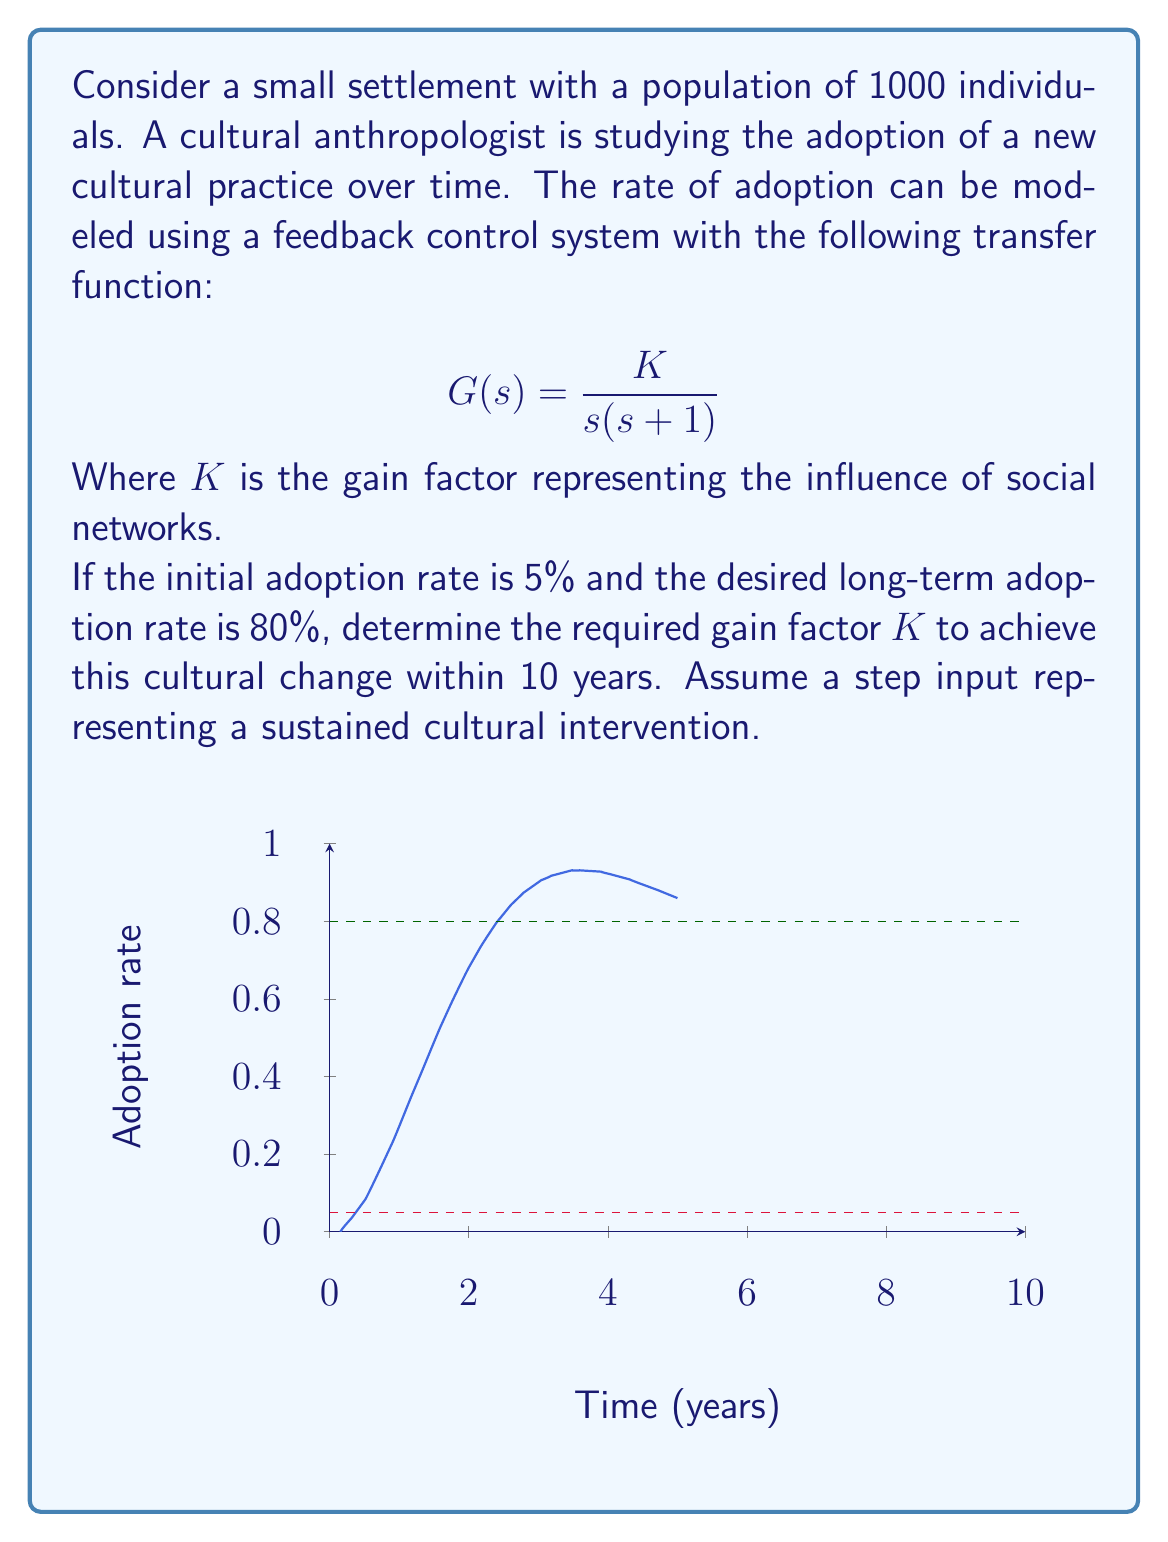Can you solve this math problem? To solve this problem, we'll follow these steps:

1) First, we need to determine the closed-loop transfer function. Given the open-loop transfer function $G(s) = \frac{K}{s(s+1)}$, the closed-loop transfer function is:

   $$T(s) = \frac{G(s)}{1+G(s)} = \frac{K}{s^2 + s + K}$$

2) The characteristic equation of this system is $s^2 + s + K = 0$. For a second-order system, we can express this in the standard form:

   $$s^2 + 2\zeta\omega_n s + \omega_n^2 = 0$$

   Where $\zeta$ is the damping ratio and $\omega_n$ is the natural frequency.

3) Comparing these equations, we can see that:
   
   $$2\zeta\omega_n = 1$$ and $$\omega_n^2 = K$$

4) For a step input, the steady-state value of the system response is:

   $$y_{ss} = \frac{K}{K} = 1$$

   This means the system will eventually reach 100% adoption, regardless of $K$.

5) To achieve 80% adoption in 10 years, we need to determine the settling time. For a 2% criterion, the settling time is approximately:

   $$T_s \approx \frac{4}{\zeta\omega_n}$$

6) We want the system to reach 80% of its final value in 10 years, so:

   $$10 = \frac{4}{\zeta\omega_n}$$

7) Solving this equation along with the relationship from step 3:

   $$\zeta\omega_n = 0.4$$ and $$2\zeta\omega_n = 1$$

   We can determine that $\zeta = 0.5$ and $\omega_n = 1$.

8) Since $\omega_n^2 = K$, we can conclude that $K = 1$.

Therefore, the required gain factor $K$ to achieve 80% adoption within 10 years is 1.
Answer: $K = 1$ 